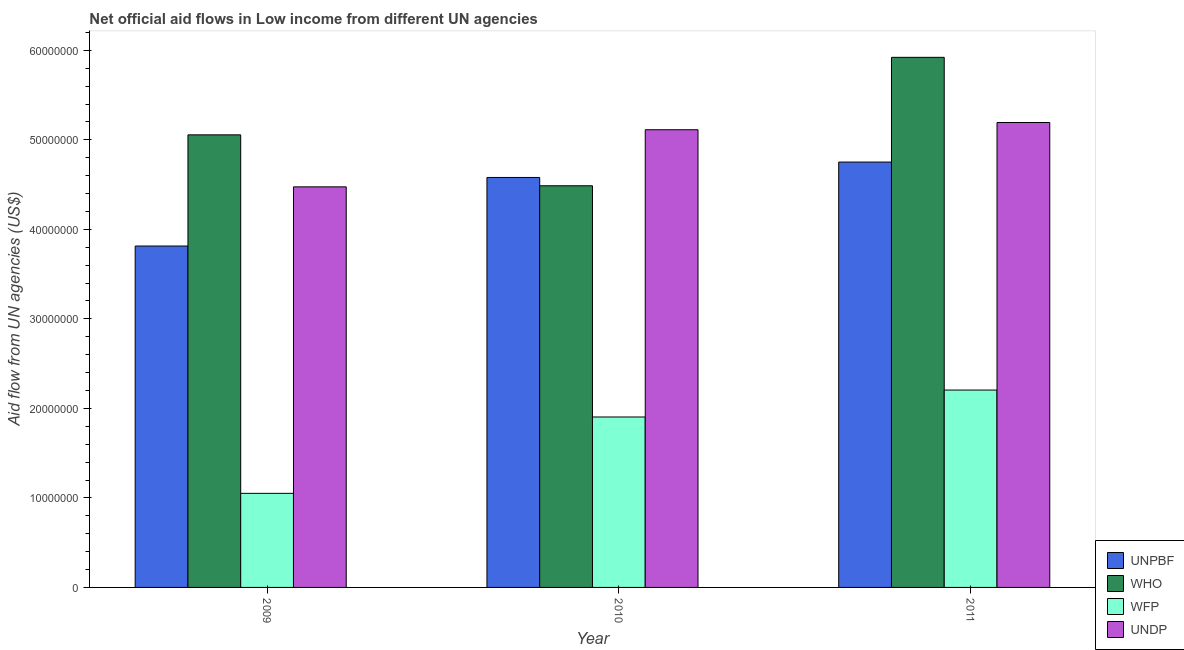How many different coloured bars are there?
Make the answer very short. 4. What is the label of the 1st group of bars from the left?
Your answer should be very brief. 2009. In how many cases, is the number of bars for a given year not equal to the number of legend labels?
Your answer should be compact. 0. What is the amount of aid given by wfp in 2011?
Ensure brevity in your answer.  2.20e+07. Across all years, what is the maximum amount of aid given by unpbf?
Give a very brief answer. 4.75e+07. Across all years, what is the minimum amount of aid given by who?
Provide a succinct answer. 4.49e+07. In which year was the amount of aid given by unpbf minimum?
Your answer should be compact. 2009. What is the total amount of aid given by undp in the graph?
Provide a succinct answer. 1.48e+08. What is the difference between the amount of aid given by unpbf in 2009 and that in 2011?
Provide a succinct answer. -9.38e+06. What is the difference between the amount of aid given by who in 2010 and the amount of aid given by undp in 2011?
Your answer should be compact. -1.44e+07. What is the average amount of aid given by unpbf per year?
Keep it short and to the point. 4.38e+07. In the year 2011, what is the difference between the amount of aid given by who and amount of aid given by unpbf?
Ensure brevity in your answer.  0. What is the ratio of the amount of aid given by undp in 2009 to that in 2011?
Make the answer very short. 0.86. Is the difference between the amount of aid given by unpbf in 2010 and 2011 greater than the difference between the amount of aid given by wfp in 2010 and 2011?
Your answer should be compact. No. What is the difference between the highest and the second highest amount of aid given by who?
Your answer should be compact. 8.66e+06. What is the difference between the highest and the lowest amount of aid given by who?
Offer a very short reply. 1.44e+07. Is the sum of the amount of aid given by wfp in 2010 and 2011 greater than the maximum amount of aid given by unpbf across all years?
Provide a short and direct response. Yes. Is it the case that in every year, the sum of the amount of aid given by who and amount of aid given by unpbf is greater than the sum of amount of aid given by undp and amount of aid given by wfp?
Provide a succinct answer. No. What does the 1st bar from the left in 2011 represents?
Offer a terse response. UNPBF. What does the 1st bar from the right in 2010 represents?
Your answer should be compact. UNDP. Is it the case that in every year, the sum of the amount of aid given by unpbf and amount of aid given by who is greater than the amount of aid given by wfp?
Make the answer very short. Yes. How many bars are there?
Your answer should be compact. 12. How many years are there in the graph?
Your answer should be compact. 3. What is the difference between two consecutive major ticks on the Y-axis?
Make the answer very short. 1.00e+07. Are the values on the major ticks of Y-axis written in scientific E-notation?
Offer a terse response. No. Does the graph contain grids?
Your response must be concise. No. Where does the legend appear in the graph?
Your answer should be compact. Bottom right. How many legend labels are there?
Provide a succinct answer. 4. How are the legend labels stacked?
Make the answer very short. Vertical. What is the title of the graph?
Give a very brief answer. Net official aid flows in Low income from different UN agencies. What is the label or title of the Y-axis?
Your answer should be compact. Aid flow from UN agencies (US$). What is the Aid flow from UN agencies (US$) of UNPBF in 2009?
Offer a very short reply. 3.81e+07. What is the Aid flow from UN agencies (US$) in WHO in 2009?
Ensure brevity in your answer.  5.06e+07. What is the Aid flow from UN agencies (US$) of WFP in 2009?
Provide a short and direct response. 1.05e+07. What is the Aid flow from UN agencies (US$) of UNDP in 2009?
Provide a succinct answer. 4.48e+07. What is the Aid flow from UN agencies (US$) of UNPBF in 2010?
Provide a succinct answer. 4.58e+07. What is the Aid flow from UN agencies (US$) of WHO in 2010?
Give a very brief answer. 4.49e+07. What is the Aid flow from UN agencies (US$) in WFP in 2010?
Ensure brevity in your answer.  1.90e+07. What is the Aid flow from UN agencies (US$) in UNDP in 2010?
Provide a succinct answer. 5.11e+07. What is the Aid flow from UN agencies (US$) of UNPBF in 2011?
Your response must be concise. 4.75e+07. What is the Aid flow from UN agencies (US$) in WHO in 2011?
Provide a succinct answer. 5.92e+07. What is the Aid flow from UN agencies (US$) of WFP in 2011?
Provide a short and direct response. 2.20e+07. What is the Aid flow from UN agencies (US$) in UNDP in 2011?
Your answer should be compact. 5.19e+07. Across all years, what is the maximum Aid flow from UN agencies (US$) in UNPBF?
Keep it short and to the point. 4.75e+07. Across all years, what is the maximum Aid flow from UN agencies (US$) in WHO?
Give a very brief answer. 5.92e+07. Across all years, what is the maximum Aid flow from UN agencies (US$) in WFP?
Your answer should be compact. 2.20e+07. Across all years, what is the maximum Aid flow from UN agencies (US$) of UNDP?
Offer a very short reply. 5.19e+07. Across all years, what is the minimum Aid flow from UN agencies (US$) in UNPBF?
Offer a terse response. 3.81e+07. Across all years, what is the minimum Aid flow from UN agencies (US$) of WHO?
Make the answer very short. 4.49e+07. Across all years, what is the minimum Aid flow from UN agencies (US$) in WFP?
Make the answer very short. 1.05e+07. Across all years, what is the minimum Aid flow from UN agencies (US$) of UNDP?
Make the answer very short. 4.48e+07. What is the total Aid flow from UN agencies (US$) of UNPBF in the graph?
Your answer should be compact. 1.31e+08. What is the total Aid flow from UN agencies (US$) in WHO in the graph?
Ensure brevity in your answer.  1.55e+08. What is the total Aid flow from UN agencies (US$) of WFP in the graph?
Give a very brief answer. 5.16e+07. What is the total Aid flow from UN agencies (US$) of UNDP in the graph?
Offer a very short reply. 1.48e+08. What is the difference between the Aid flow from UN agencies (US$) in UNPBF in 2009 and that in 2010?
Make the answer very short. -7.66e+06. What is the difference between the Aid flow from UN agencies (US$) of WHO in 2009 and that in 2010?
Give a very brief answer. 5.69e+06. What is the difference between the Aid flow from UN agencies (US$) in WFP in 2009 and that in 2010?
Offer a terse response. -8.53e+06. What is the difference between the Aid flow from UN agencies (US$) in UNDP in 2009 and that in 2010?
Ensure brevity in your answer.  -6.38e+06. What is the difference between the Aid flow from UN agencies (US$) of UNPBF in 2009 and that in 2011?
Your answer should be very brief. -9.38e+06. What is the difference between the Aid flow from UN agencies (US$) in WHO in 2009 and that in 2011?
Provide a short and direct response. -8.66e+06. What is the difference between the Aid flow from UN agencies (US$) in WFP in 2009 and that in 2011?
Your response must be concise. -1.15e+07. What is the difference between the Aid flow from UN agencies (US$) of UNDP in 2009 and that in 2011?
Offer a very short reply. -7.19e+06. What is the difference between the Aid flow from UN agencies (US$) of UNPBF in 2010 and that in 2011?
Your response must be concise. -1.72e+06. What is the difference between the Aid flow from UN agencies (US$) of WHO in 2010 and that in 2011?
Ensure brevity in your answer.  -1.44e+07. What is the difference between the Aid flow from UN agencies (US$) in WFP in 2010 and that in 2011?
Ensure brevity in your answer.  -3.01e+06. What is the difference between the Aid flow from UN agencies (US$) in UNDP in 2010 and that in 2011?
Your answer should be very brief. -8.10e+05. What is the difference between the Aid flow from UN agencies (US$) in UNPBF in 2009 and the Aid flow from UN agencies (US$) in WHO in 2010?
Your answer should be very brief. -6.73e+06. What is the difference between the Aid flow from UN agencies (US$) of UNPBF in 2009 and the Aid flow from UN agencies (US$) of WFP in 2010?
Provide a short and direct response. 1.91e+07. What is the difference between the Aid flow from UN agencies (US$) in UNPBF in 2009 and the Aid flow from UN agencies (US$) in UNDP in 2010?
Make the answer very short. -1.30e+07. What is the difference between the Aid flow from UN agencies (US$) in WHO in 2009 and the Aid flow from UN agencies (US$) in WFP in 2010?
Provide a succinct answer. 3.15e+07. What is the difference between the Aid flow from UN agencies (US$) of WHO in 2009 and the Aid flow from UN agencies (US$) of UNDP in 2010?
Offer a very short reply. -5.70e+05. What is the difference between the Aid flow from UN agencies (US$) in WFP in 2009 and the Aid flow from UN agencies (US$) in UNDP in 2010?
Your answer should be very brief. -4.06e+07. What is the difference between the Aid flow from UN agencies (US$) of UNPBF in 2009 and the Aid flow from UN agencies (US$) of WHO in 2011?
Offer a very short reply. -2.11e+07. What is the difference between the Aid flow from UN agencies (US$) in UNPBF in 2009 and the Aid flow from UN agencies (US$) in WFP in 2011?
Make the answer very short. 1.61e+07. What is the difference between the Aid flow from UN agencies (US$) in UNPBF in 2009 and the Aid flow from UN agencies (US$) in UNDP in 2011?
Your answer should be compact. -1.38e+07. What is the difference between the Aid flow from UN agencies (US$) in WHO in 2009 and the Aid flow from UN agencies (US$) in WFP in 2011?
Your answer should be very brief. 2.85e+07. What is the difference between the Aid flow from UN agencies (US$) in WHO in 2009 and the Aid flow from UN agencies (US$) in UNDP in 2011?
Your answer should be very brief. -1.38e+06. What is the difference between the Aid flow from UN agencies (US$) of WFP in 2009 and the Aid flow from UN agencies (US$) of UNDP in 2011?
Give a very brief answer. -4.14e+07. What is the difference between the Aid flow from UN agencies (US$) in UNPBF in 2010 and the Aid flow from UN agencies (US$) in WHO in 2011?
Provide a short and direct response. -1.34e+07. What is the difference between the Aid flow from UN agencies (US$) in UNPBF in 2010 and the Aid flow from UN agencies (US$) in WFP in 2011?
Give a very brief answer. 2.38e+07. What is the difference between the Aid flow from UN agencies (US$) in UNPBF in 2010 and the Aid flow from UN agencies (US$) in UNDP in 2011?
Keep it short and to the point. -6.14e+06. What is the difference between the Aid flow from UN agencies (US$) in WHO in 2010 and the Aid flow from UN agencies (US$) in WFP in 2011?
Give a very brief answer. 2.28e+07. What is the difference between the Aid flow from UN agencies (US$) of WHO in 2010 and the Aid flow from UN agencies (US$) of UNDP in 2011?
Give a very brief answer. -7.07e+06. What is the difference between the Aid flow from UN agencies (US$) of WFP in 2010 and the Aid flow from UN agencies (US$) of UNDP in 2011?
Make the answer very short. -3.29e+07. What is the average Aid flow from UN agencies (US$) of UNPBF per year?
Provide a short and direct response. 4.38e+07. What is the average Aid flow from UN agencies (US$) of WHO per year?
Ensure brevity in your answer.  5.16e+07. What is the average Aid flow from UN agencies (US$) of WFP per year?
Your answer should be compact. 1.72e+07. What is the average Aid flow from UN agencies (US$) of UNDP per year?
Provide a short and direct response. 4.93e+07. In the year 2009, what is the difference between the Aid flow from UN agencies (US$) of UNPBF and Aid flow from UN agencies (US$) of WHO?
Provide a short and direct response. -1.24e+07. In the year 2009, what is the difference between the Aid flow from UN agencies (US$) in UNPBF and Aid flow from UN agencies (US$) in WFP?
Ensure brevity in your answer.  2.76e+07. In the year 2009, what is the difference between the Aid flow from UN agencies (US$) in UNPBF and Aid flow from UN agencies (US$) in UNDP?
Ensure brevity in your answer.  -6.61e+06. In the year 2009, what is the difference between the Aid flow from UN agencies (US$) in WHO and Aid flow from UN agencies (US$) in WFP?
Provide a short and direct response. 4.00e+07. In the year 2009, what is the difference between the Aid flow from UN agencies (US$) in WHO and Aid flow from UN agencies (US$) in UNDP?
Provide a succinct answer. 5.81e+06. In the year 2009, what is the difference between the Aid flow from UN agencies (US$) in WFP and Aid flow from UN agencies (US$) in UNDP?
Ensure brevity in your answer.  -3.42e+07. In the year 2010, what is the difference between the Aid flow from UN agencies (US$) of UNPBF and Aid flow from UN agencies (US$) of WHO?
Your response must be concise. 9.30e+05. In the year 2010, what is the difference between the Aid flow from UN agencies (US$) in UNPBF and Aid flow from UN agencies (US$) in WFP?
Provide a succinct answer. 2.68e+07. In the year 2010, what is the difference between the Aid flow from UN agencies (US$) in UNPBF and Aid flow from UN agencies (US$) in UNDP?
Provide a succinct answer. -5.33e+06. In the year 2010, what is the difference between the Aid flow from UN agencies (US$) of WHO and Aid flow from UN agencies (US$) of WFP?
Ensure brevity in your answer.  2.58e+07. In the year 2010, what is the difference between the Aid flow from UN agencies (US$) of WHO and Aid flow from UN agencies (US$) of UNDP?
Your answer should be compact. -6.26e+06. In the year 2010, what is the difference between the Aid flow from UN agencies (US$) of WFP and Aid flow from UN agencies (US$) of UNDP?
Provide a succinct answer. -3.21e+07. In the year 2011, what is the difference between the Aid flow from UN agencies (US$) in UNPBF and Aid flow from UN agencies (US$) in WHO?
Your answer should be compact. -1.17e+07. In the year 2011, what is the difference between the Aid flow from UN agencies (US$) of UNPBF and Aid flow from UN agencies (US$) of WFP?
Provide a succinct answer. 2.55e+07. In the year 2011, what is the difference between the Aid flow from UN agencies (US$) of UNPBF and Aid flow from UN agencies (US$) of UNDP?
Give a very brief answer. -4.42e+06. In the year 2011, what is the difference between the Aid flow from UN agencies (US$) in WHO and Aid flow from UN agencies (US$) in WFP?
Your answer should be compact. 3.72e+07. In the year 2011, what is the difference between the Aid flow from UN agencies (US$) in WHO and Aid flow from UN agencies (US$) in UNDP?
Give a very brief answer. 7.28e+06. In the year 2011, what is the difference between the Aid flow from UN agencies (US$) of WFP and Aid flow from UN agencies (US$) of UNDP?
Your answer should be compact. -2.99e+07. What is the ratio of the Aid flow from UN agencies (US$) in UNPBF in 2009 to that in 2010?
Your response must be concise. 0.83. What is the ratio of the Aid flow from UN agencies (US$) in WHO in 2009 to that in 2010?
Keep it short and to the point. 1.13. What is the ratio of the Aid flow from UN agencies (US$) of WFP in 2009 to that in 2010?
Your response must be concise. 0.55. What is the ratio of the Aid flow from UN agencies (US$) of UNDP in 2009 to that in 2010?
Make the answer very short. 0.88. What is the ratio of the Aid flow from UN agencies (US$) in UNPBF in 2009 to that in 2011?
Provide a succinct answer. 0.8. What is the ratio of the Aid flow from UN agencies (US$) of WHO in 2009 to that in 2011?
Keep it short and to the point. 0.85. What is the ratio of the Aid flow from UN agencies (US$) in WFP in 2009 to that in 2011?
Provide a short and direct response. 0.48. What is the ratio of the Aid flow from UN agencies (US$) of UNDP in 2009 to that in 2011?
Your answer should be compact. 0.86. What is the ratio of the Aid flow from UN agencies (US$) of UNPBF in 2010 to that in 2011?
Offer a very short reply. 0.96. What is the ratio of the Aid flow from UN agencies (US$) in WHO in 2010 to that in 2011?
Offer a terse response. 0.76. What is the ratio of the Aid flow from UN agencies (US$) of WFP in 2010 to that in 2011?
Your response must be concise. 0.86. What is the ratio of the Aid flow from UN agencies (US$) in UNDP in 2010 to that in 2011?
Provide a short and direct response. 0.98. What is the difference between the highest and the second highest Aid flow from UN agencies (US$) in UNPBF?
Your response must be concise. 1.72e+06. What is the difference between the highest and the second highest Aid flow from UN agencies (US$) in WHO?
Provide a succinct answer. 8.66e+06. What is the difference between the highest and the second highest Aid flow from UN agencies (US$) of WFP?
Your response must be concise. 3.01e+06. What is the difference between the highest and the second highest Aid flow from UN agencies (US$) of UNDP?
Offer a terse response. 8.10e+05. What is the difference between the highest and the lowest Aid flow from UN agencies (US$) of UNPBF?
Your answer should be very brief. 9.38e+06. What is the difference between the highest and the lowest Aid flow from UN agencies (US$) of WHO?
Offer a very short reply. 1.44e+07. What is the difference between the highest and the lowest Aid flow from UN agencies (US$) of WFP?
Provide a succinct answer. 1.15e+07. What is the difference between the highest and the lowest Aid flow from UN agencies (US$) of UNDP?
Provide a short and direct response. 7.19e+06. 